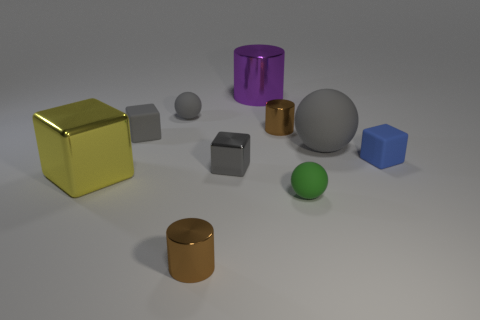Subtract all purple metal cylinders. How many cylinders are left? 2 Subtract all green balls. How many balls are left? 2 Subtract 3 cylinders. How many cylinders are left? 0 Subtract all green blocks. Subtract all red balls. How many blocks are left? 4 Subtract all purple blocks. How many gray balls are left? 2 Subtract all small yellow metallic cubes. Subtract all blue rubber cubes. How many objects are left? 9 Add 8 brown metal objects. How many brown metal objects are left? 10 Add 3 tiny matte things. How many tiny matte things exist? 7 Subtract 1 blue blocks. How many objects are left? 9 Subtract all cylinders. How many objects are left? 7 